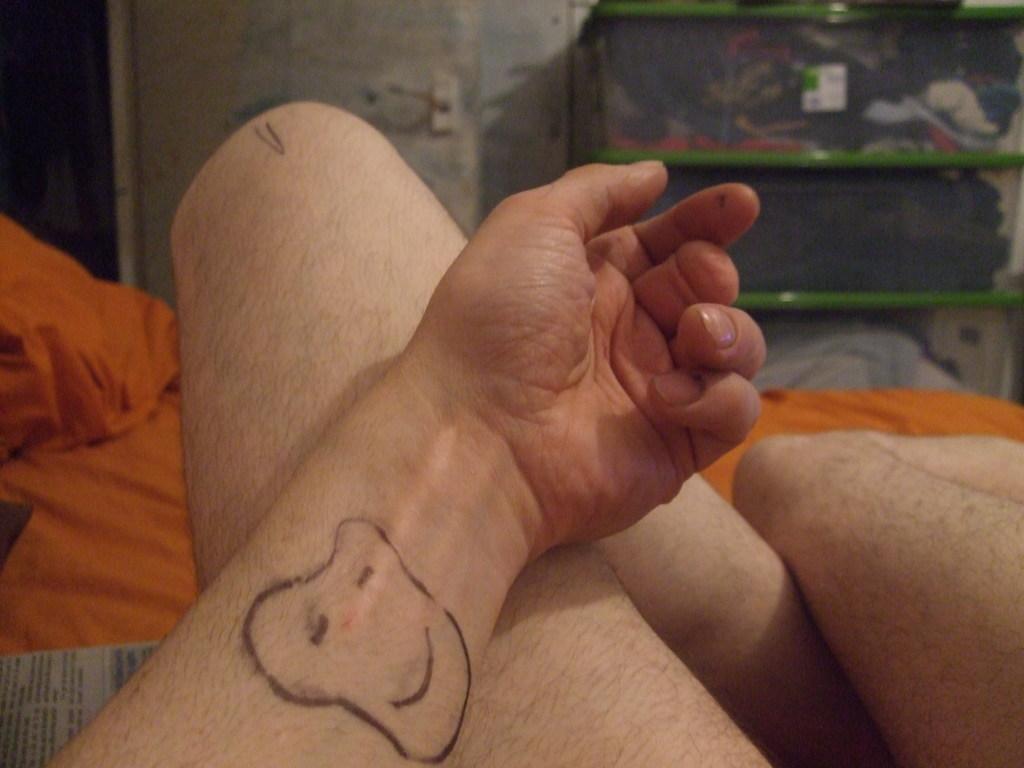Please provide a concise description of this image. In this image at the bottom there is one person and there are some blankets and news paper, in the background there is one box and a wall. 